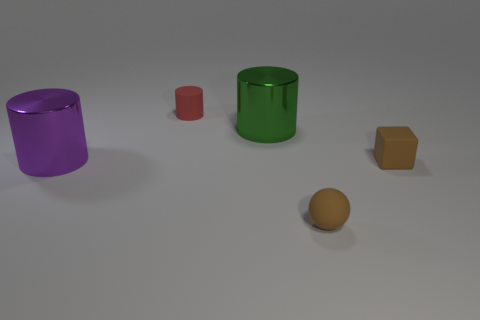Are there any brown things that have the same shape as the big purple metal thing?
Your answer should be compact. No. What number of red rubber things have the same shape as the green metallic thing?
Offer a very short reply. 1. Do the small cube and the sphere have the same color?
Your answer should be very brief. Yes. Is the number of matte cylinders less than the number of purple metallic balls?
Provide a short and direct response. No. What is the material of the thing that is right of the tiny matte sphere?
Your answer should be compact. Rubber. What material is the cylinder that is the same size as the cube?
Make the answer very short. Rubber. What is the cube that is in front of the big thing left of the metal cylinder on the right side of the tiny matte cylinder made of?
Ensure brevity in your answer.  Rubber. Is the size of the metal object left of the green object the same as the sphere?
Offer a terse response. No. Is the number of small blue matte things greater than the number of large green things?
Make the answer very short. No. How many large objects are red cylinders or brown things?
Make the answer very short. 0. 